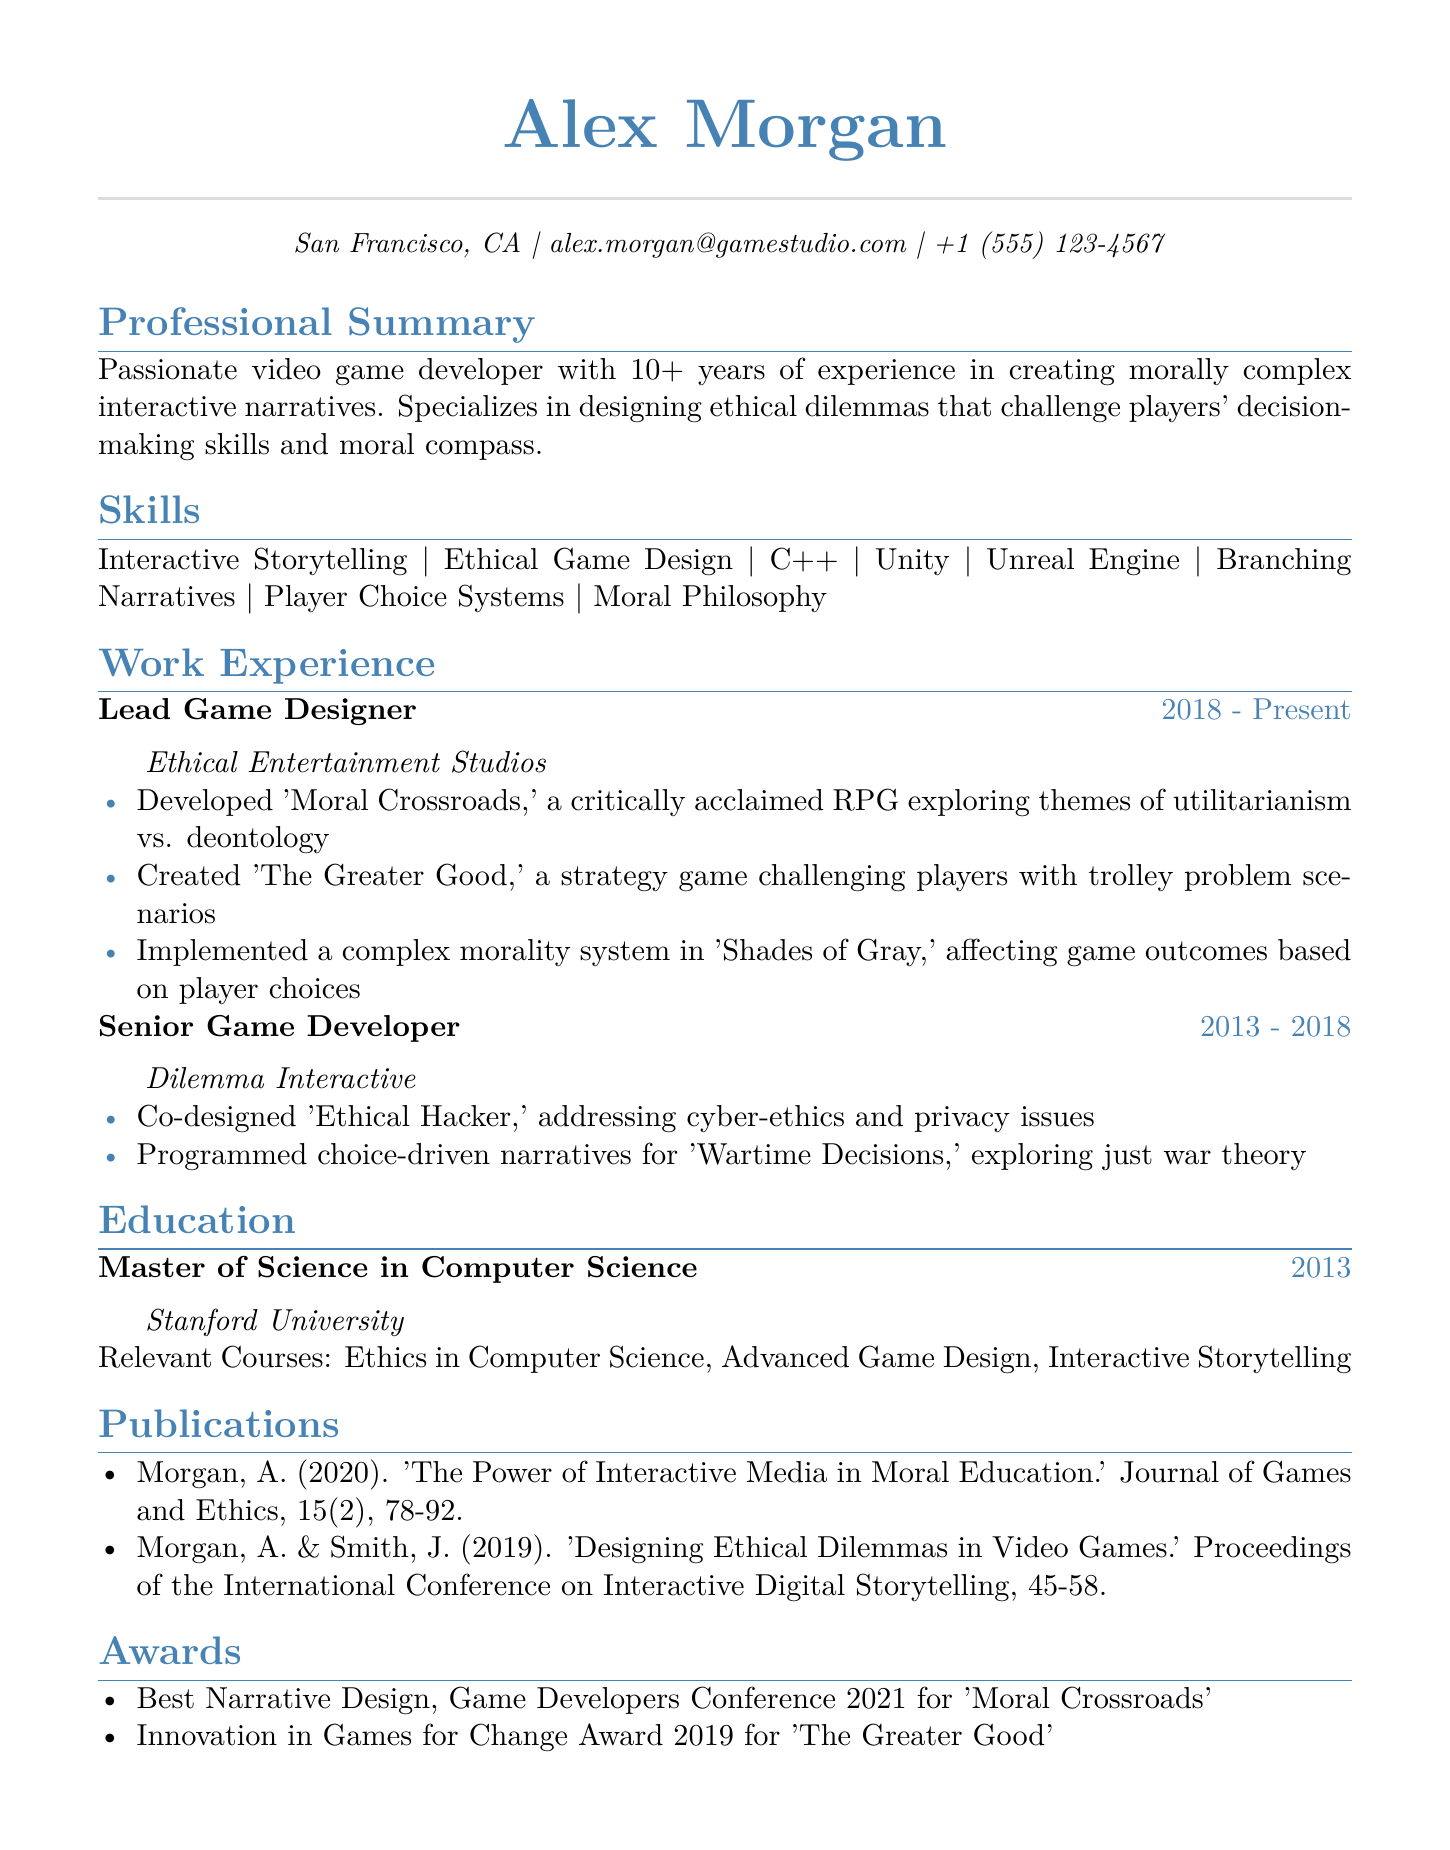What is the name of the lead game designer? The lead game designer's name is listed at the top of the CV.
Answer: Alex Morgan What is the duration of Alex's role at Ethical Entertainment Studios? This information is indicated in the work experience section of the CV.
Answer: 2018 - Present Which game won the Best Narrative Design award in 2021? The CV lists the games that received awards in the awards section.
Answer: Moral Crossroads What ethical themes are explored in 'Moral Crossroads'? The details of the game's themes are provided in the achievements of the work experience section.
Answer: Utilitarianism vs. deontology How many years of experience does Alex have in video game development? The professional summary mentions Alex's years of experience in the field.
Answer: 10+ What degree did Alex obtain from Stanford University? This information can be found in the education section of the CV.
Answer: Master of Science in Computer Science Which publication discusses the power of interactive media in moral education? The publication titles are listed under the publications section of the CV.
Answer: The Power of Interactive Media in Moral Education What is one of the main skills listed on the CV? The skills section contains various competencies relevant to the profession.
Answer: Interactive Storytelling Which company did Alex work for before joining Ethical Entertainment Studios? The CV details Alex's work history in the work experience section.
Answer: Dilemma Interactive 